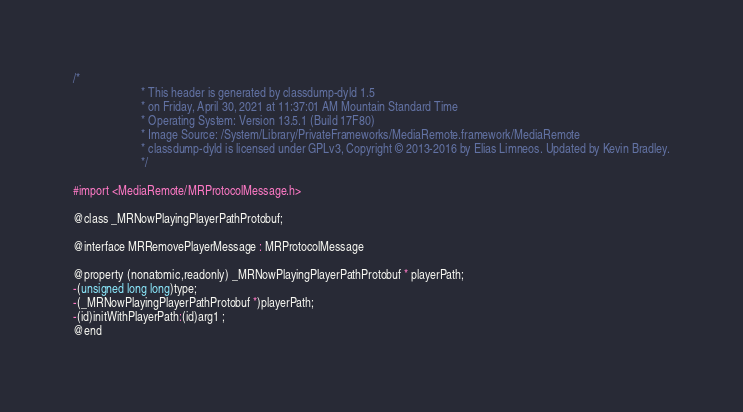<code> <loc_0><loc_0><loc_500><loc_500><_C_>/*
                       * This header is generated by classdump-dyld 1.5
                       * on Friday, April 30, 2021 at 11:37:01 AM Mountain Standard Time
                       * Operating System: Version 13.5.1 (Build 17F80)
                       * Image Source: /System/Library/PrivateFrameworks/MediaRemote.framework/MediaRemote
                       * classdump-dyld is licensed under GPLv3, Copyright © 2013-2016 by Elias Limneos. Updated by Kevin Bradley.
                       */

#import <MediaRemote/MRProtocolMessage.h>

@class _MRNowPlayingPlayerPathProtobuf;

@interface MRRemovePlayerMessage : MRProtocolMessage

@property (nonatomic,readonly) _MRNowPlayingPlayerPathProtobuf * playerPath; 
-(unsigned long long)type;
-(_MRNowPlayingPlayerPathProtobuf *)playerPath;
-(id)initWithPlayerPath:(id)arg1 ;
@end

</code> 